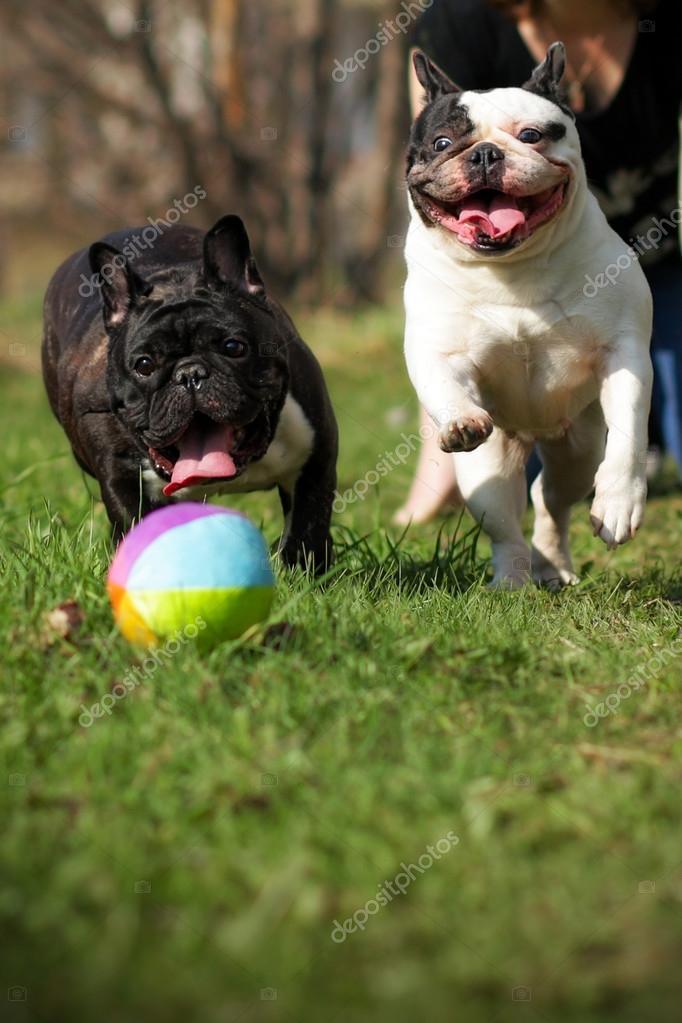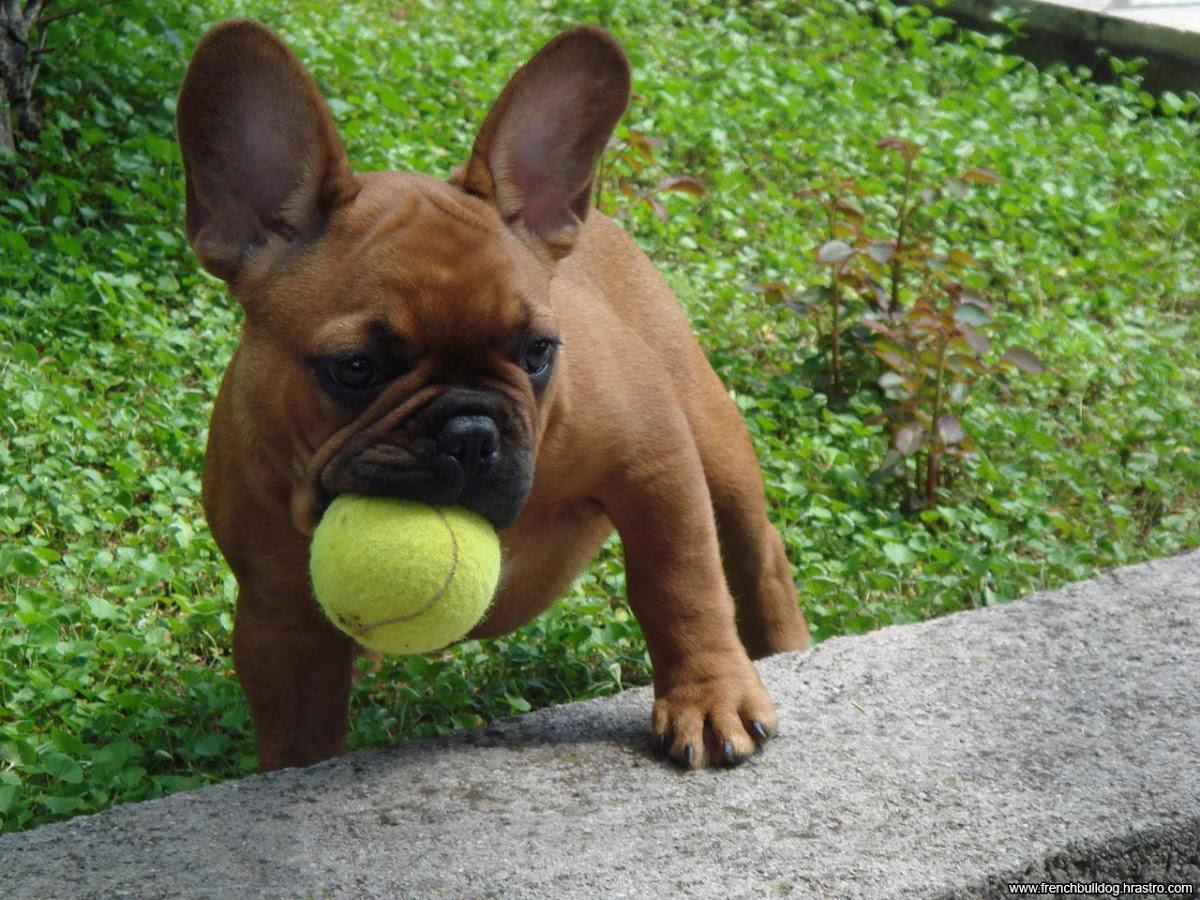The first image is the image on the left, the second image is the image on the right. Evaluate the accuracy of this statement regarding the images: "An image shows a brown dog playing with a yellow tennis ball in an area with green ground.". Is it true? Answer yes or no. Yes. The first image is the image on the left, the second image is the image on the right. For the images shown, is this caption "The dog in the image on the right is playing with a yellow ball." true? Answer yes or no. Yes. 